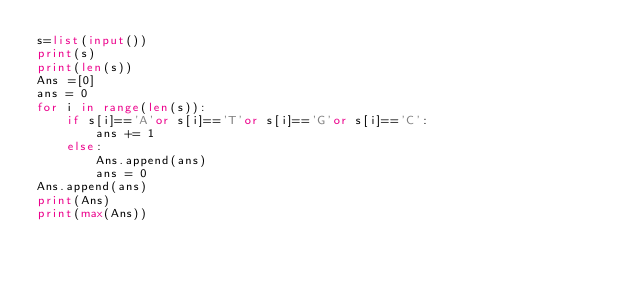<code> <loc_0><loc_0><loc_500><loc_500><_Python_>s=list(input())
print(s)
print(len(s))
Ans =[0]
ans = 0
for i in range(len(s)):
    if s[i]=='A'or s[i]=='T'or s[i]=='G'or s[i]=='C':
        ans += 1
    else:
        Ans.append(ans)
        ans = 0
Ans.append(ans)
print(Ans)
print(max(Ans))
</code> 